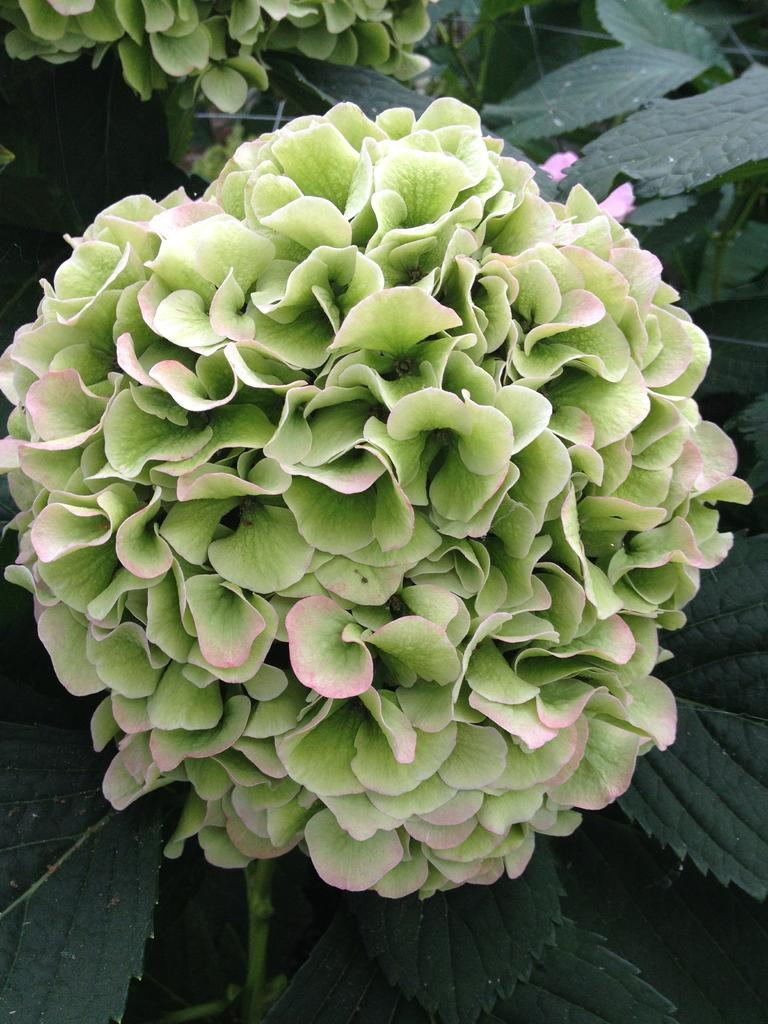What is the main subject in the middle of the image? There is a flower in the middle of the image. What can be seen in the background of the image? There are green leaves in the background of the image. What is located at the bottom of the image? There is a plant at the bottom of the image. What else can be seen in the image besides the flower in the middle? There is another flower at the top of the image. What type of invention is being demonstrated in the image? There is no invention present in the image; it features flowers and green leaves. Is there a collar visible on the flower in the image? There is no collar present on the flower in the image. 